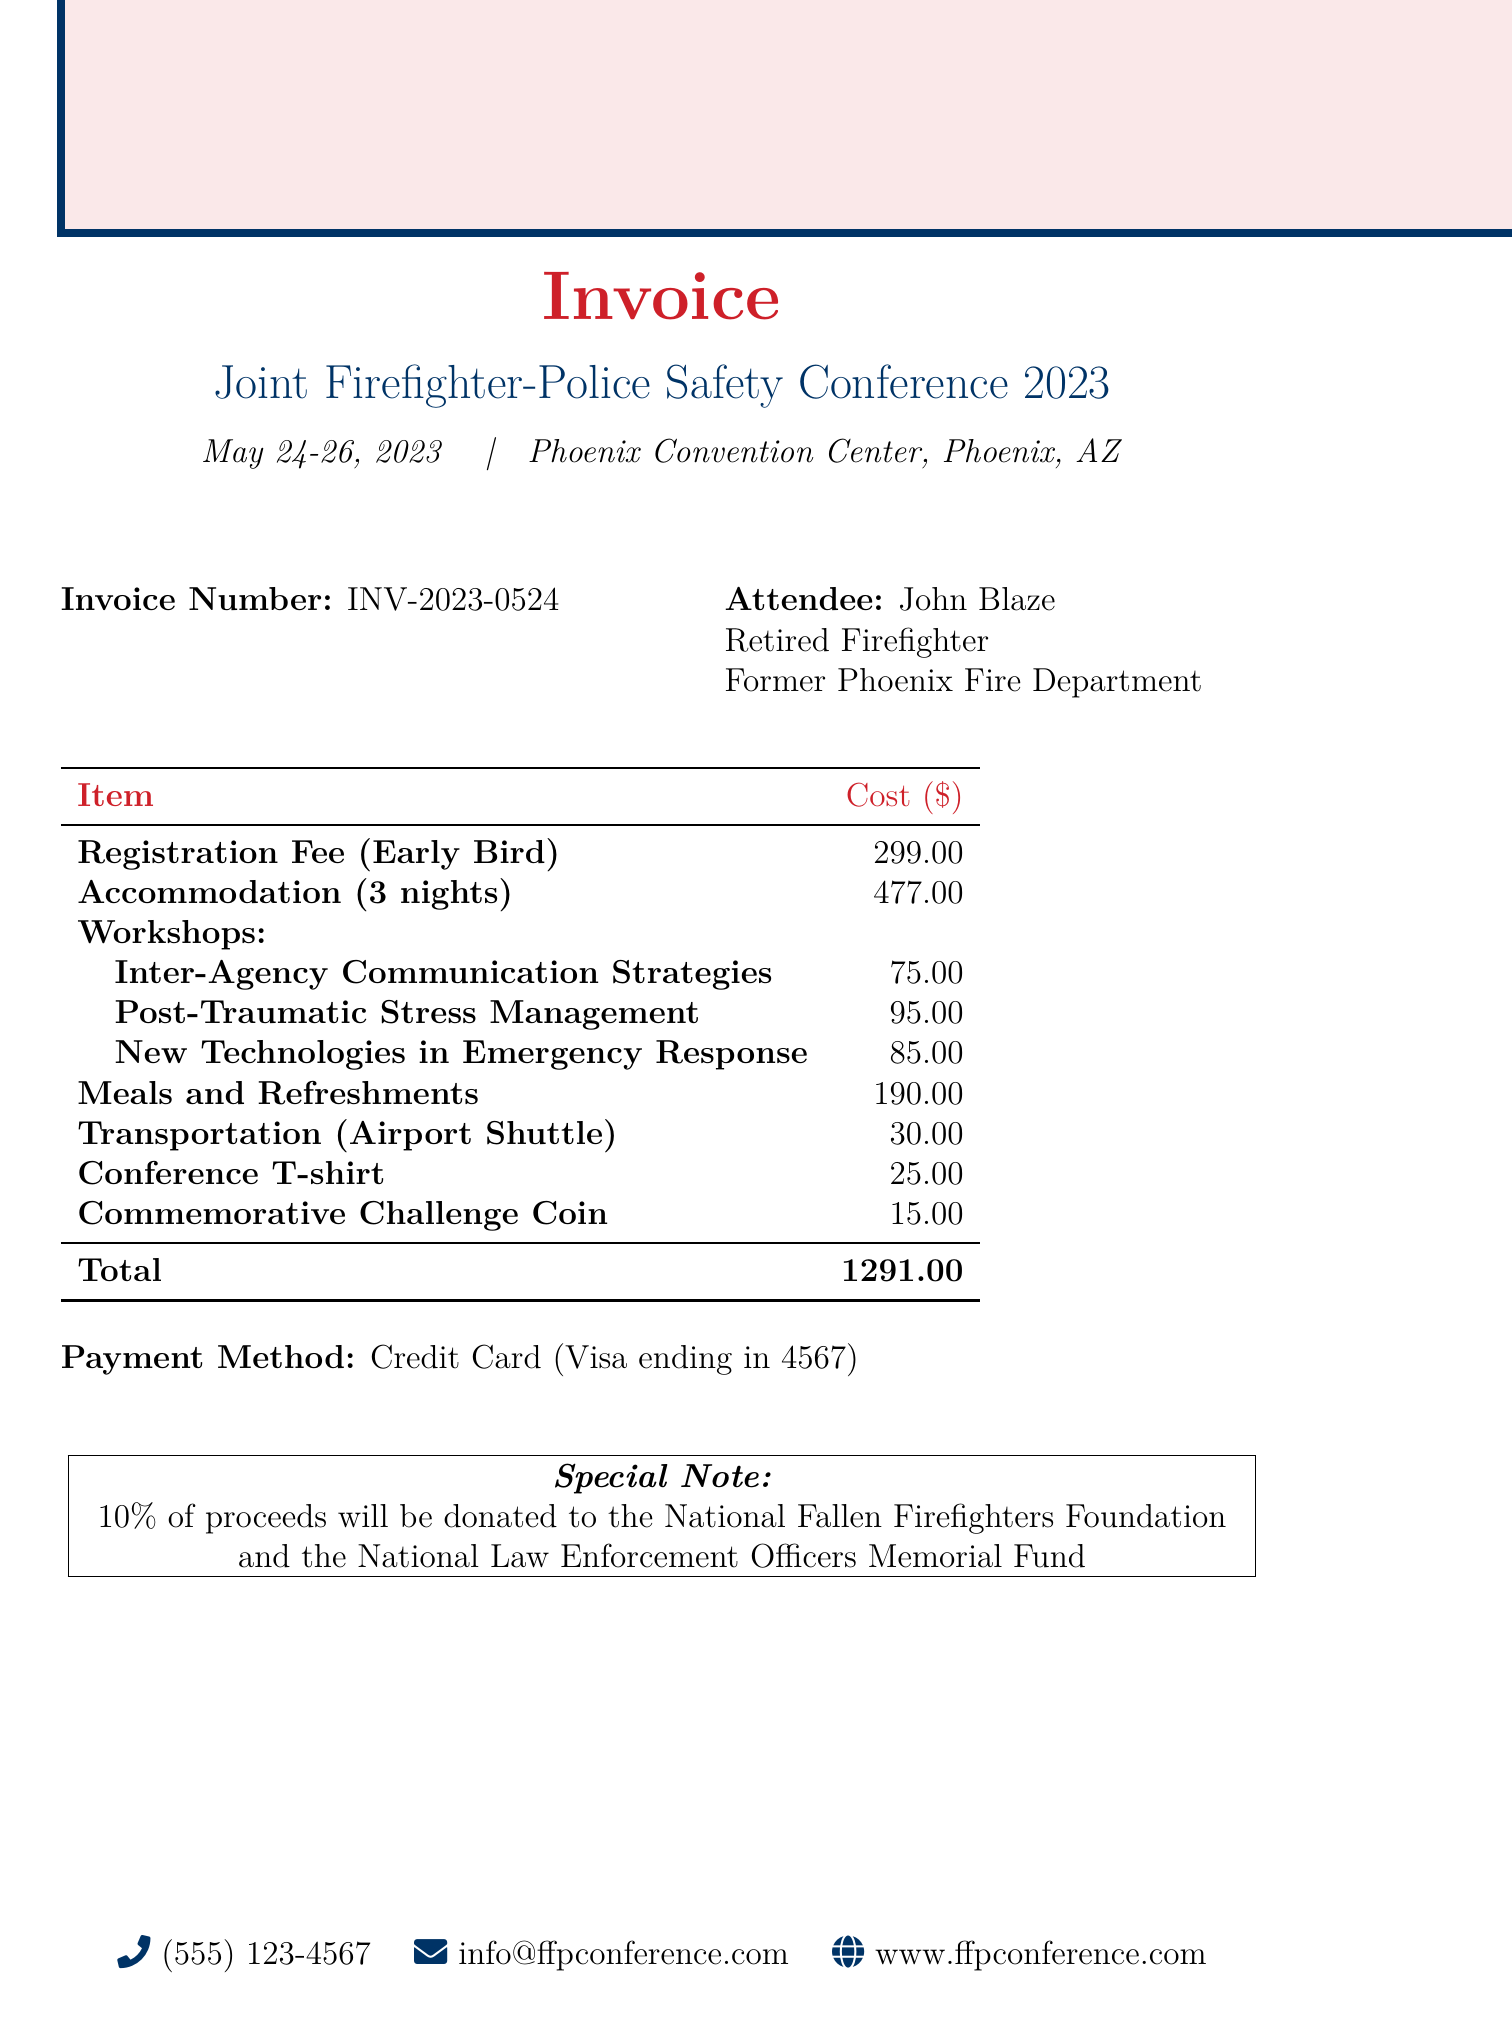What is the invoice number? The invoice number is clearly labeled in the document.
Answer: INV-2023-0524 Who is the attendee? The document states the name and occupation of the attendee.
Answer: John Blaze What is the total accommodation cost? The total accommodation cost is listed under the accommodation section.
Answer: 477.00 What are the names of the workshops? The document provides the names of the workshops offered at the conference.
Answer: Inter-Agency Communication Strategies, Post-Traumatic Stress Management for First Responders, New Technologies in Emergency Response How much is the early bird registration fee after discount? The fee structure shows the original and discounted registration fees.
Answer: 299.00 What is the total cost of meals and refreshments? The total cost for meals and refreshments is summed up in the document.
Answer: 190.00 How many nights of accommodation were booked? The night count for accommodation is explicitly mentioned.
Answer: 3 What payment method was used? The payment method is specified toward the end of the document.
Answer: Credit Card (Visa ending in 4567) What percentage of proceeds will be donated? The special note at the bottom of the document specifies the donation percentage.
Answer: 10% 